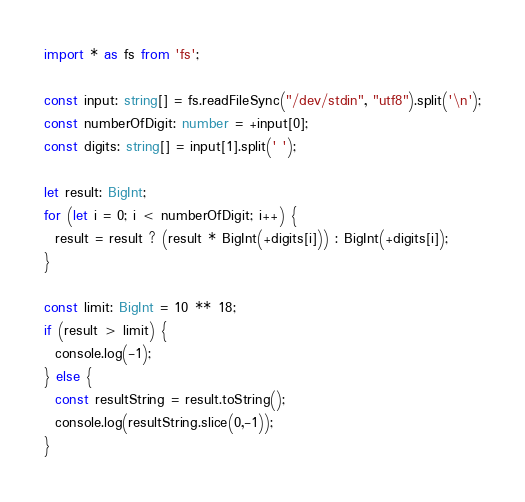<code> <loc_0><loc_0><loc_500><loc_500><_TypeScript_>import * as fs from 'fs';

const input: string[] = fs.readFileSync("/dev/stdin", "utf8").split('\n');
const numberOfDigit: number = +input[0];
const digits: string[] = input[1].split(' ');

let result: BigInt;
for (let i = 0; i < numberOfDigit; i++) {
  result = result ? (result * BigInt(+digits[i])) : BigInt(+digits[i]);
}

const limit: BigInt = 10 ** 18;
if (result > limit) {
  console.log(-1);
} else {
  const resultString = result.toString();
  console.log(resultString.slice(0,-1));
}</code> 